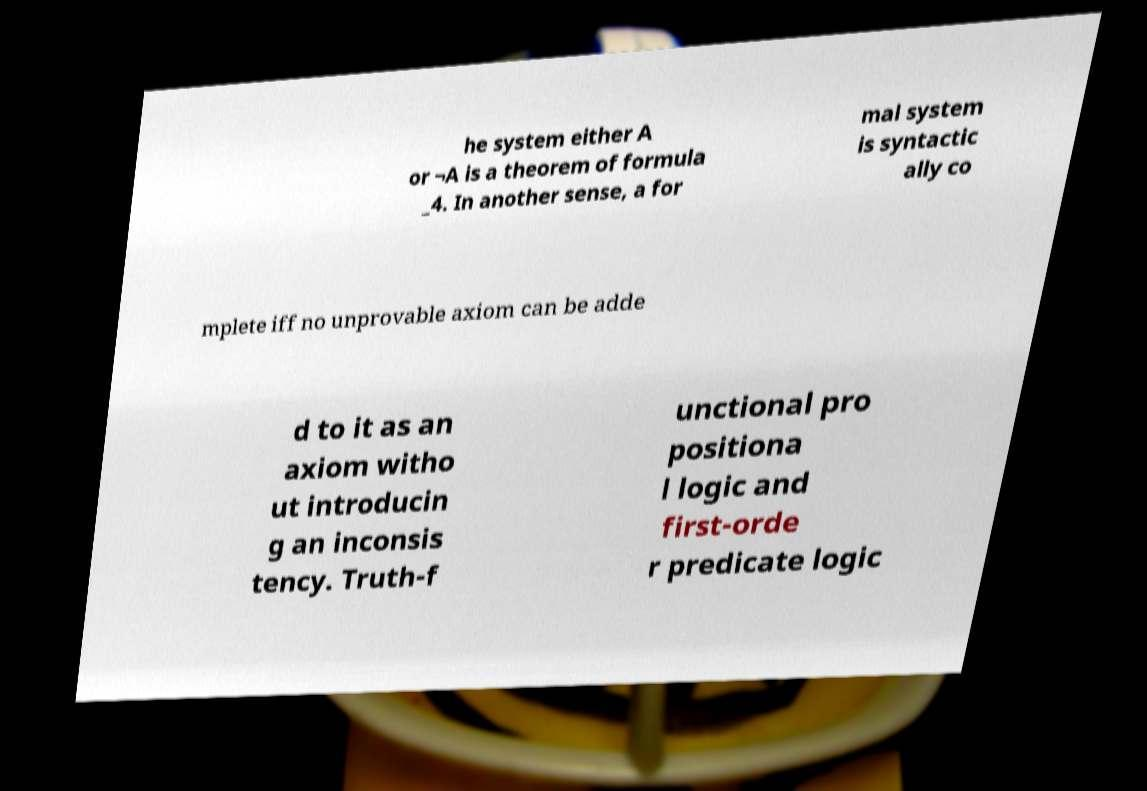For documentation purposes, I need the text within this image transcribed. Could you provide that? he system either A or ¬A is a theorem of formula _4. In another sense, a for mal system is syntactic ally co mplete iff no unprovable axiom can be adde d to it as an axiom witho ut introducin g an inconsis tency. Truth-f unctional pro positiona l logic and first-orde r predicate logic 